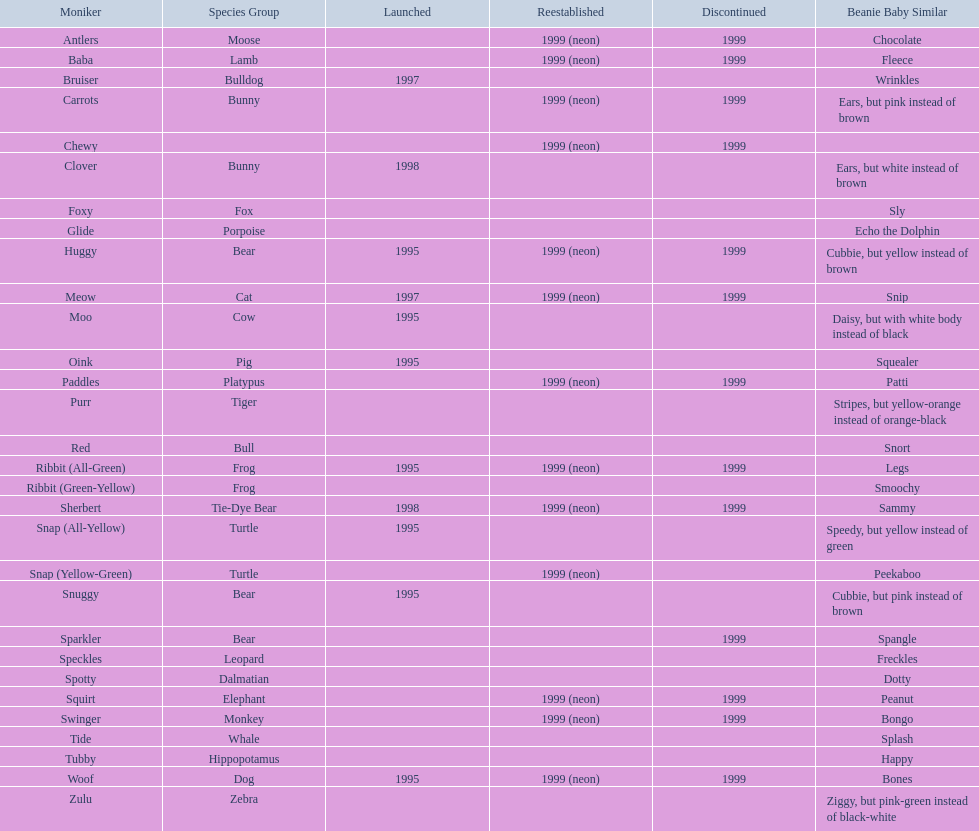Which of the listed pillow pals lack information in at least 3 categories? Chewy, Foxy, Glide, Purr, Red, Ribbit (Green-Yellow), Speckles, Spotty, Tide, Tubby, Zulu. Of those, which one lacks information in the animal type category? Chewy. 